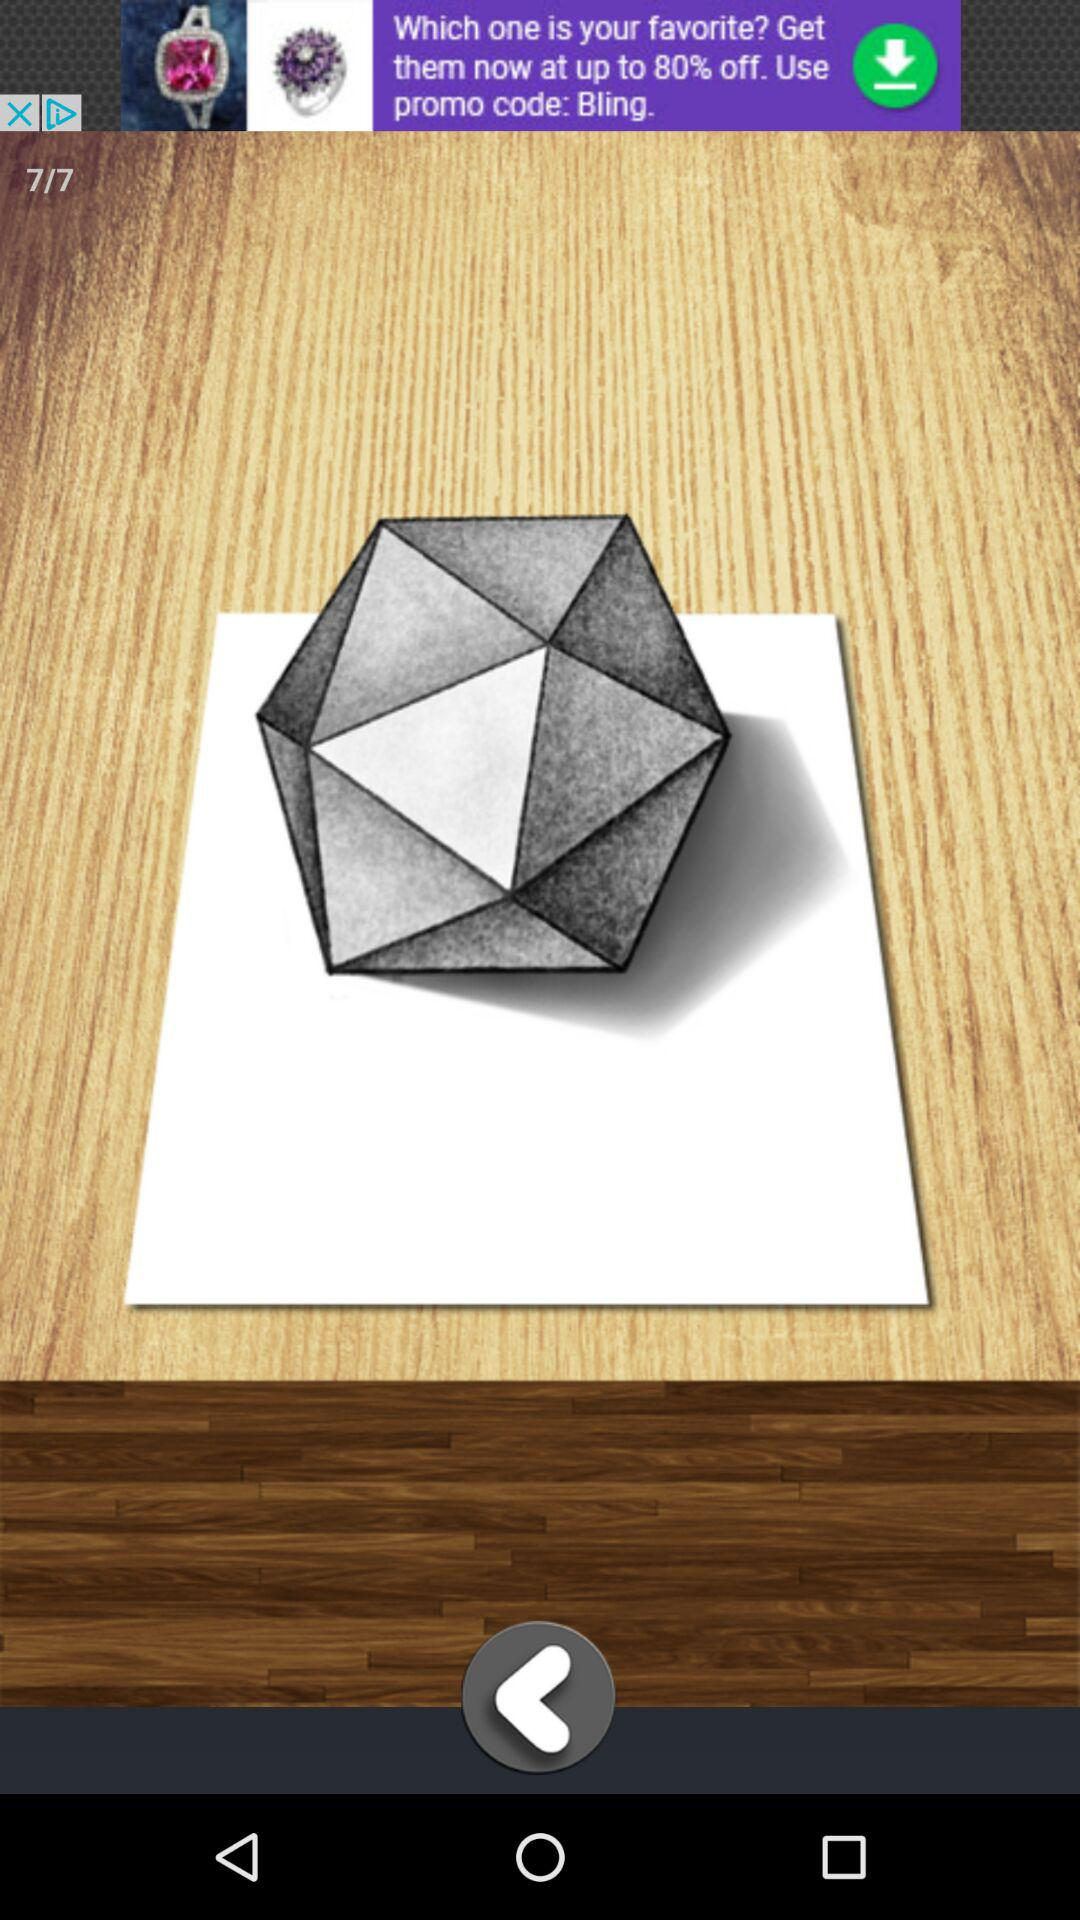What is the total number of images? The total number of images is 7. 